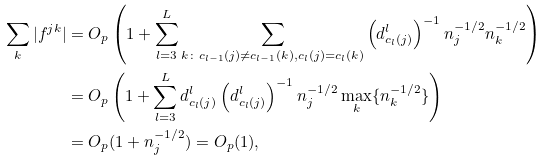Convert formula to latex. <formula><loc_0><loc_0><loc_500><loc_500>\sum _ { k } | f ^ { j k } | & = O _ { p } \left ( 1 + \sum _ { l = 3 } ^ { L } \sum _ { k \colon c _ { l - 1 } ( j ) \not = c _ { l - 1 } ( k ) , c _ { l } ( j ) = c _ { l } ( k ) } \left ( d ^ { l } _ { c _ { l } ( j ) } \right ) ^ { - 1 } n _ { j } ^ { - 1 / 2 } n _ { k } ^ { - 1 / 2 } \right ) \\ & = O _ { p } \left ( 1 + \sum _ { l = 3 } ^ { L } d ^ { l } _ { c _ { l } ( j ) } \left ( d ^ { l } _ { c _ { l } ( j ) } \right ) ^ { - 1 } n _ { j } ^ { - 1 / 2 } \max _ { k } \{ n _ { k } ^ { - 1 / 2 } \} \right ) \\ & = O _ { p } ( 1 + n _ { j } ^ { - 1 / 2 } ) = O _ { p } ( 1 ) ,</formula> 